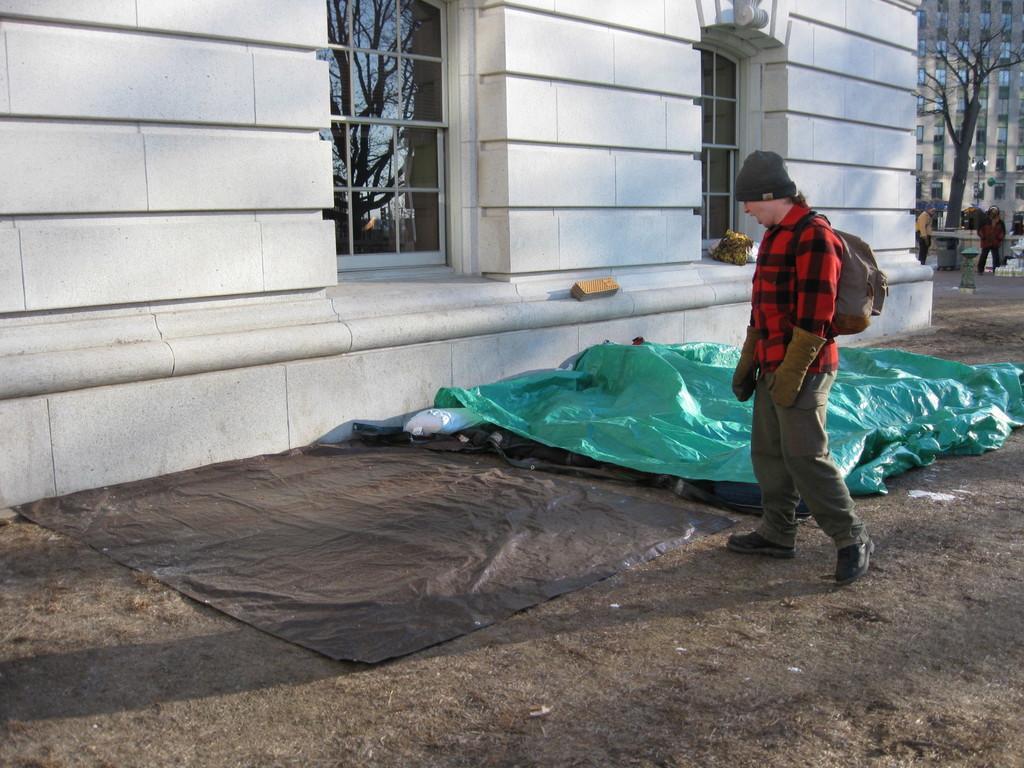How would you summarize this image in a sentence or two? In this image we can see buildings, tree, sheets, people and things. One person wore a bag and cap. On this window glass there is a reflection of a tree and sky.  